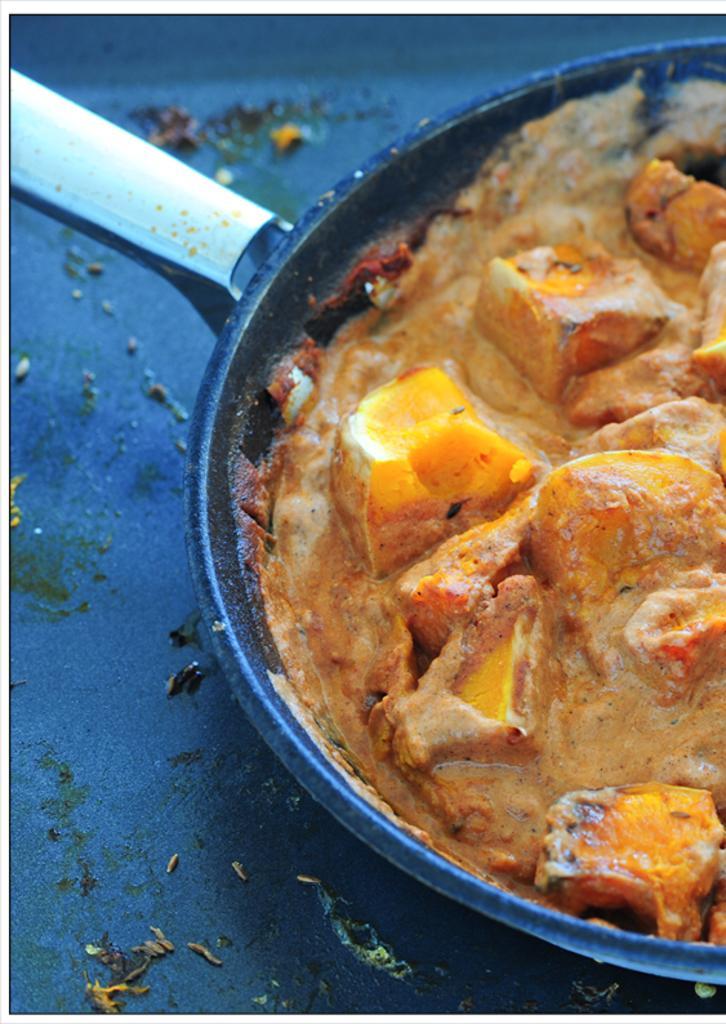Can you describe this image briefly? In this image I can see a pan in which food items are there may be kept on the floor. This image is taken may be in a room. 